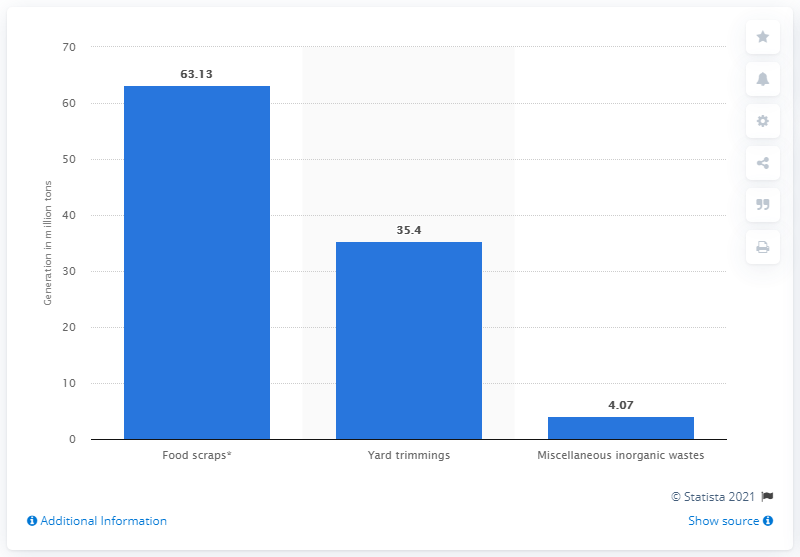Give some essential details in this illustration. In 2018, the United States generated approximately 63,130 tons of food waste in its municipal solid waste stream. 